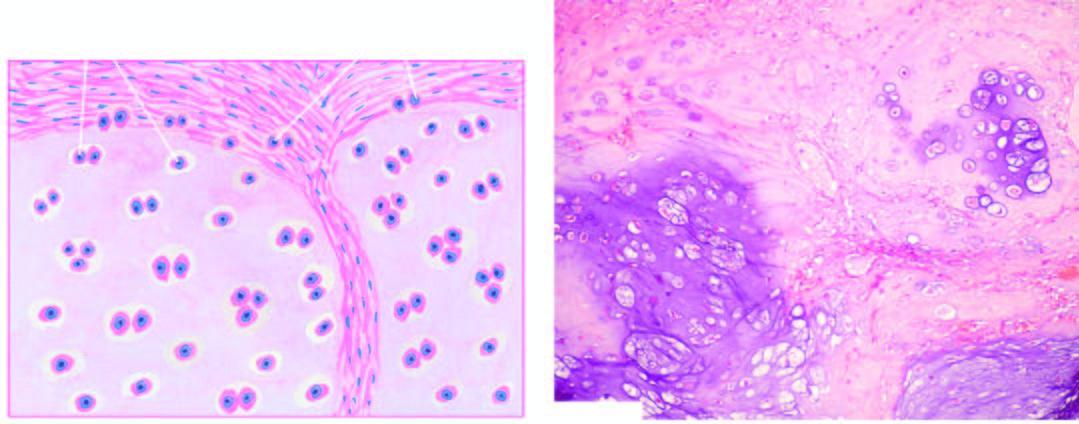what include invasion of the tumour into adjacent soft tissues and cytologic characteristics of malignancy in the tumour cells?
Answer the question using a single word or phrase. Histologic features 